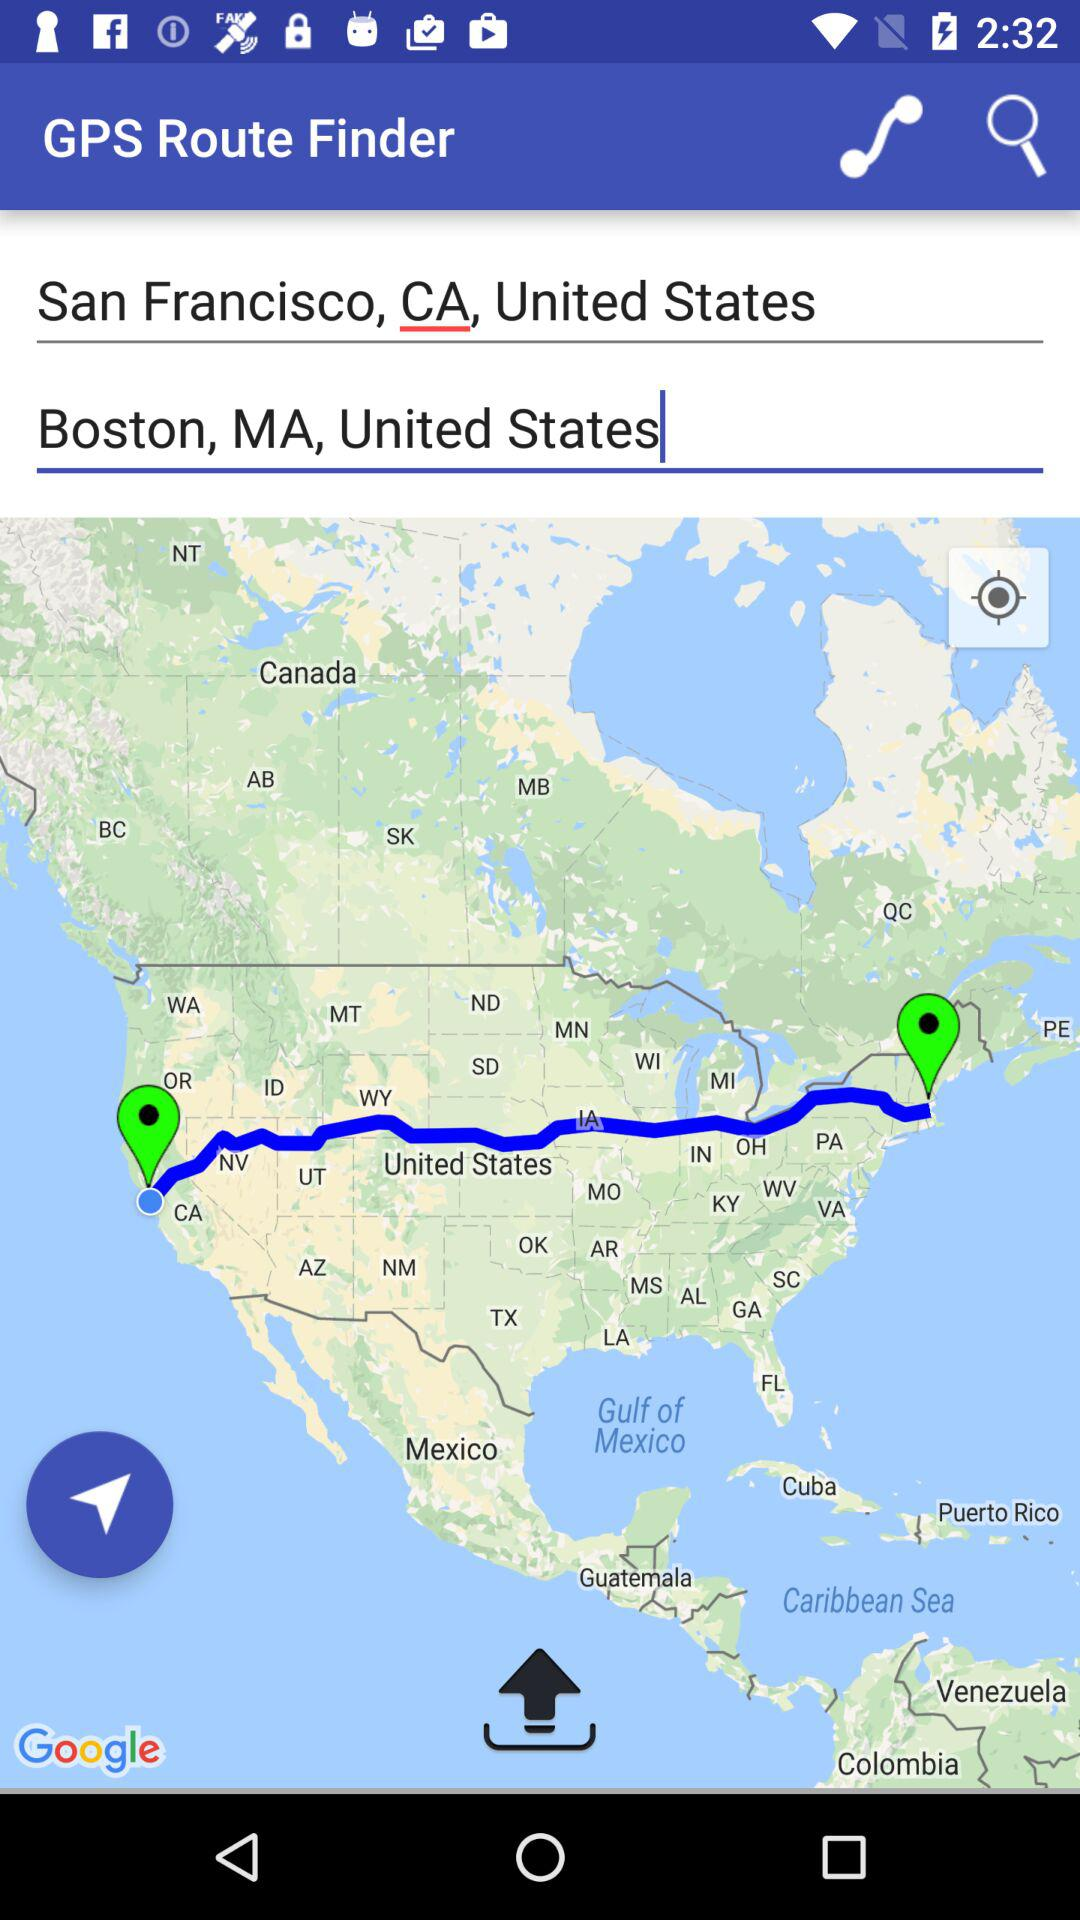How many cities are there?
Answer the question using a single word or phrase. 2 